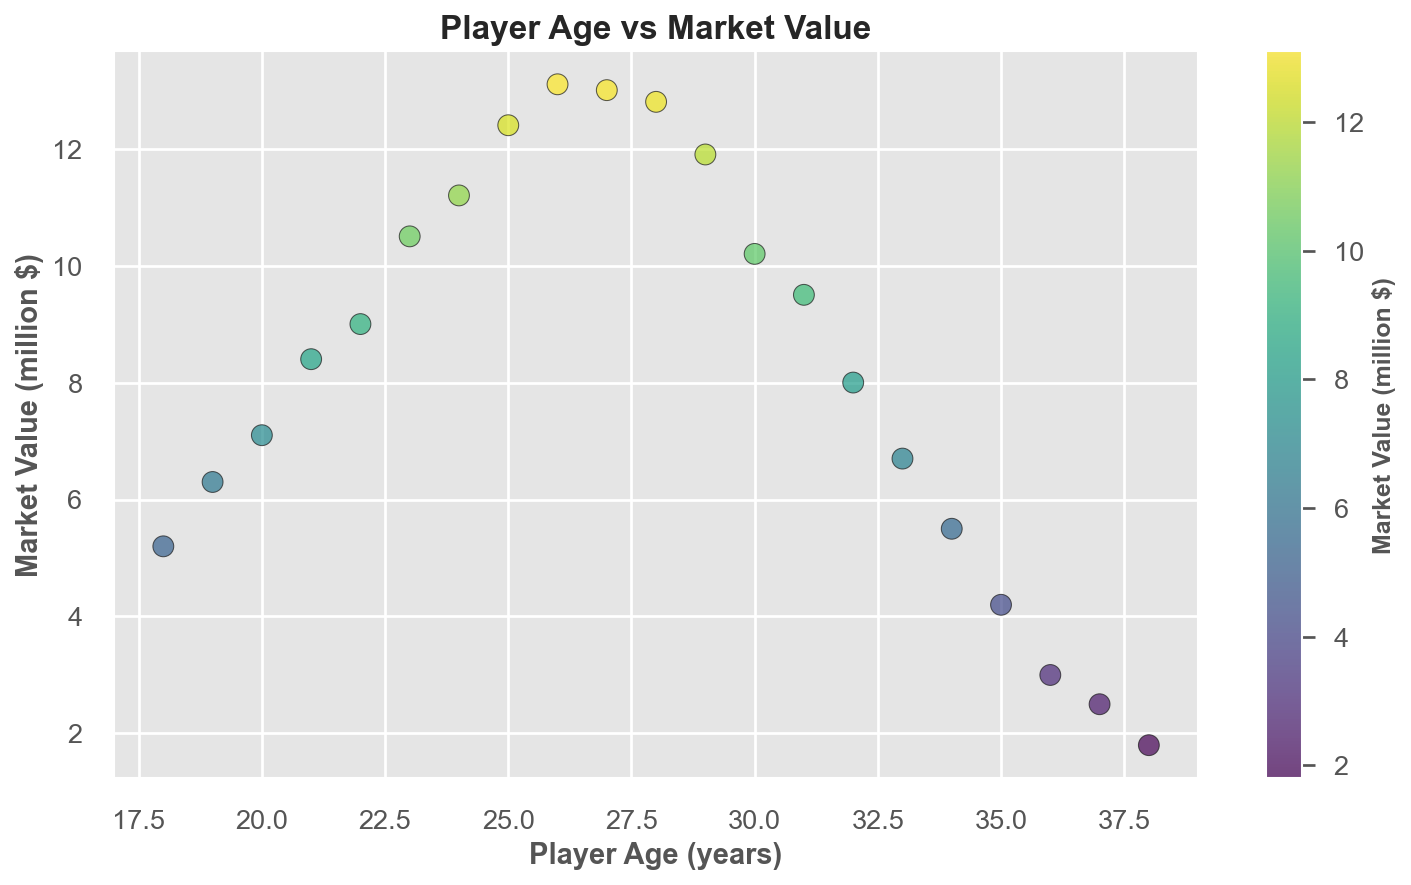What age of players shows the highest market value? Look at the scatter plot and identify the dot with the highest position on the market value axis, then check the corresponding age.
Answer: 26 years old How does the market value trend between ages 26 to 31? Examine the scatter plot to see how the dots are positioned as age increases from 26 to 31. Notice the pattern or direction of the dots representing market values within these age ranges.
Answer: Decreasing trend Is there a significant drop in market value after a certain age? If so, after which age? Look for a steep decline in the position of dots on the market value axis correlated with higher ages. Identify the age after which this drop starts.
Answer: After 30 years Compare the market value of players aged 25 and 33. Which age has a higher market value? Find the dots corresponding to ages 25 and 33, and compare their heights on the market value axis. The higher dot indicates the higher market value.
Answer: 25 years old What is the approximate market value of a 20-year-old player? Locate the dot that corresponds to the age of 20 on the scatter plot and read its position on the market value axis.
Answer: 7.1 million $ How does player age affect market value visually on the scatter plot? Observe the pattern and direction the dots follow from younger to older ages—check if they generally move upward or downward as age increases.
Answer: Increases up to mid-20s, then decreases What is the average market value of players aged 21, 26, and 31? Find the market values for ages 21 (8.4), 26 (13.1), and 31 (9.5), sum them up, and then divide by 3 for the average. (8.4 + 13.1 + 9.5) / 3
Answer: 10.3 million $ Do players aged 29 or 30 have a higher market value? Compare the heights of the dots corresponding to ages 29 and 30 on the market value axis.
Answer: 29 years old How does the color of the dots change as the market value increases? Observe the color gradient from low to high market values and describe the color shift as values get higher.
Answer: Changes from dark to bright What is the market value difference between the youngest and oldest players? Identify the market values for the youngest (18: 5.2) and the oldest players (38: 1.8), then subtract the smaller value from the larger one. 5.2 - 1.8
Answer: 3.4 million $ 